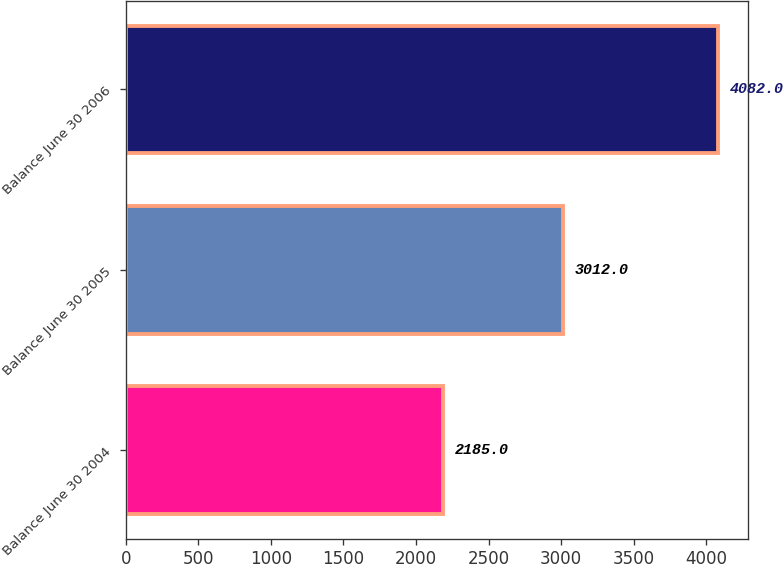Convert chart to OTSL. <chart><loc_0><loc_0><loc_500><loc_500><bar_chart><fcel>Balance June 30 2004<fcel>Balance June 30 2005<fcel>Balance June 30 2006<nl><fcel>2185<fcel>3012<fcel>4082<nl></chart> 